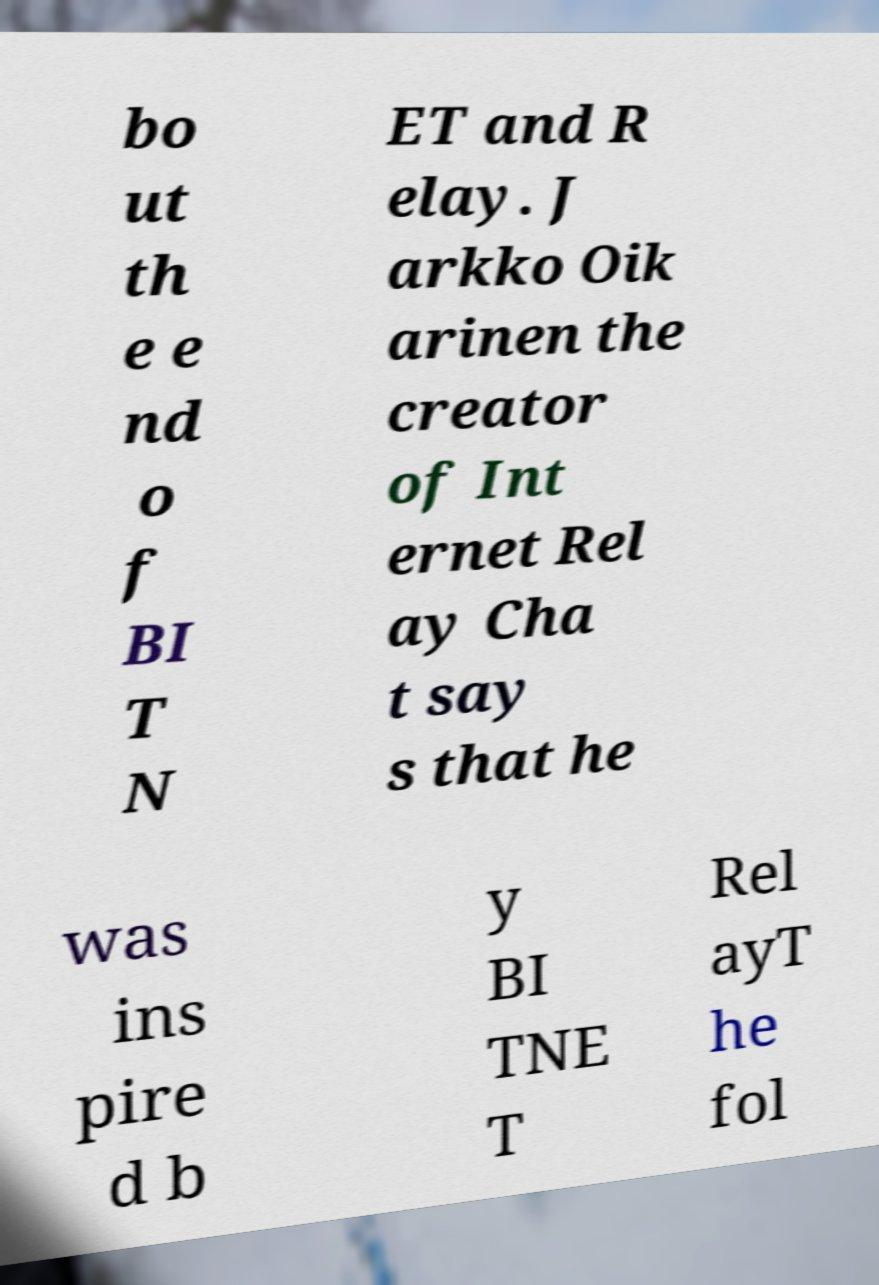For documentation purposes, I need the text within this image transcribed. Could you provide that? bo ut th e e nd o f BI T N ET and R elay. J arkko Oik arinen the creator of Int ernet Rel ay Cha t say s that he was ins pire d b y BI TNE T Rel ayT he fol 